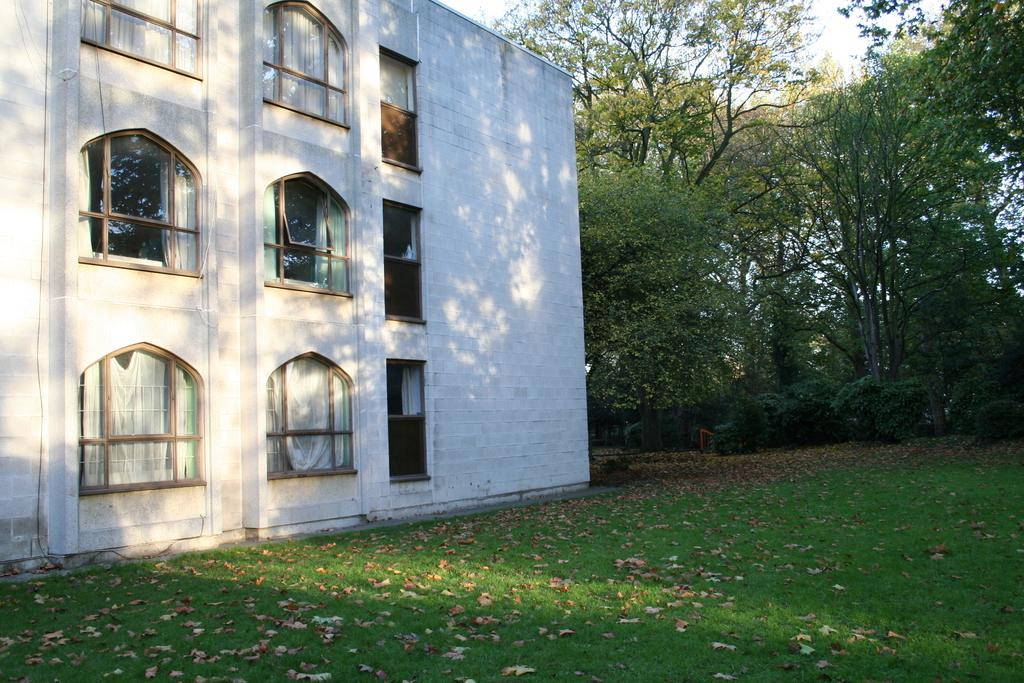What type of vegetation can be seen on the grass in the image? There are leaves on the grass in the image. What type of structure is present in the image? There is a building in the image. What is another feature of the building in the image? There is a wall in the image. What part of the building can be seen through in the image? There are windows in the image. What can be seen in the background of the image? Trees and the sky are visible in the background of the image. What type of pickle is being used as a decoration on the wall in the image? There is no pickle present in the image; it is a building with a wall and windows. Can you hear the band playing in the background of the image? There is no band present in the image, so it is not possible to hear them playing. 